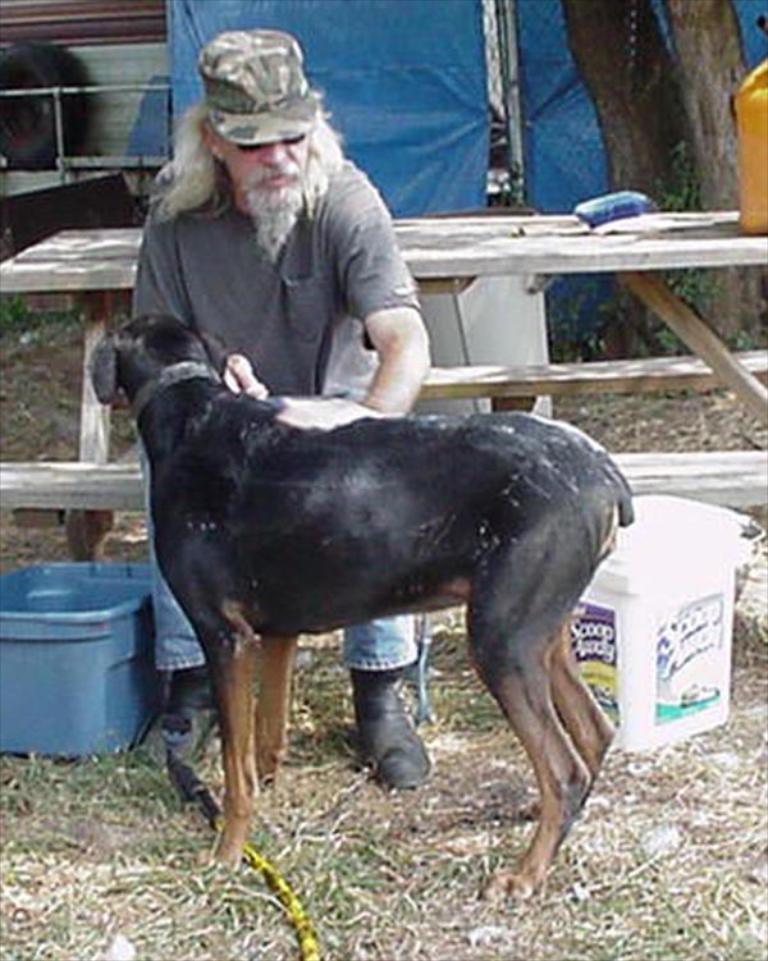Please provide a concise description of this image. In this image, we can see a person and a dog. We can see the ground with some objects. We can also see some grass and the wooden bench. We can also see an object on the right. In the background, we can see the blue colored object and the fence. We can also see the trunk of a tree. We can see a tyre. 